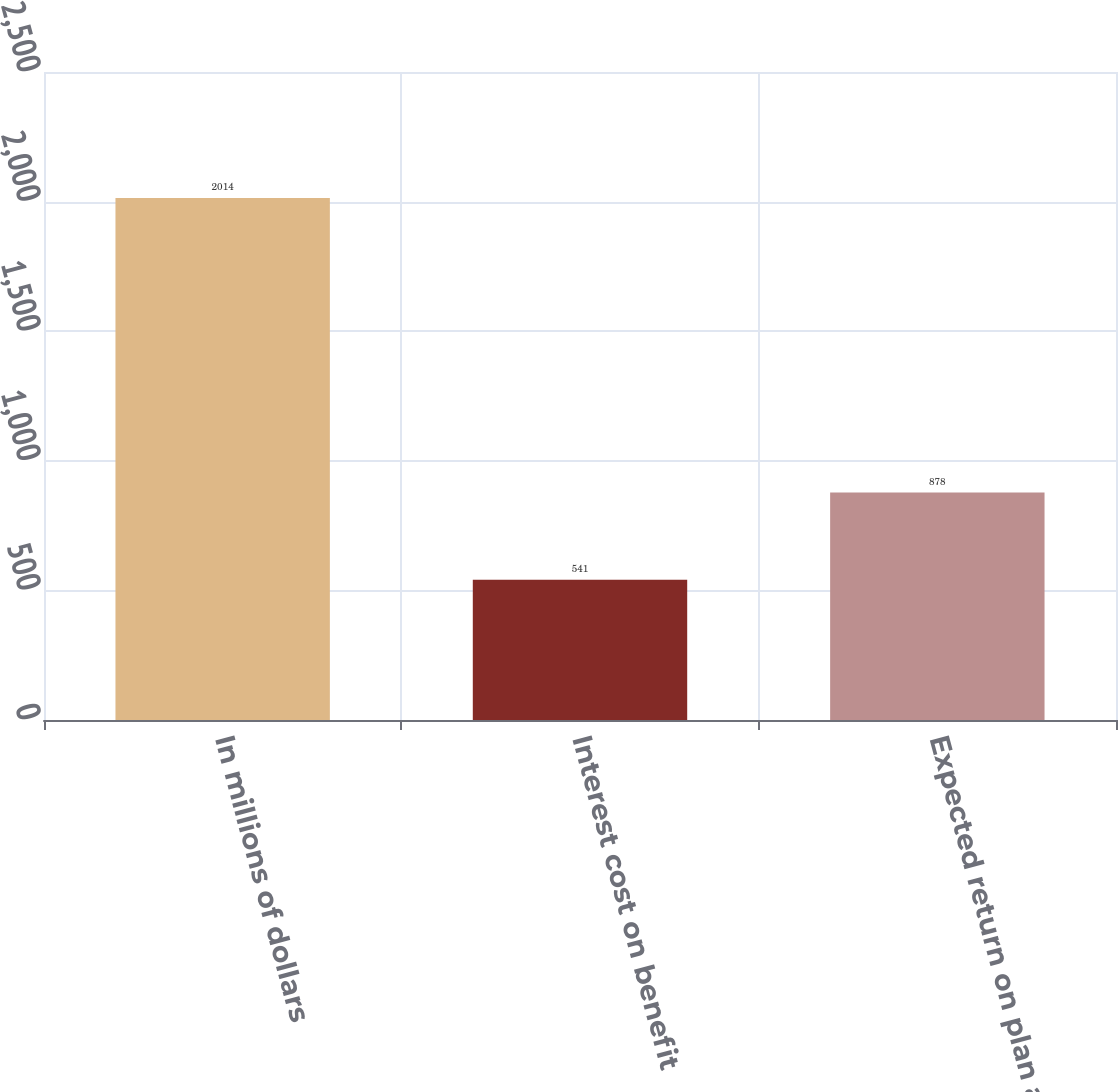Convert chart to OTSL. <chart><loc_0><loc_0><loc_500><loc_500><bar_chart><fcel>In millions of dollars<fcel>Interest cost on benefit<fcel>Expected return on plan assets<nl><fcel>2014<fcel>541<fcel>878<nl></chart> 